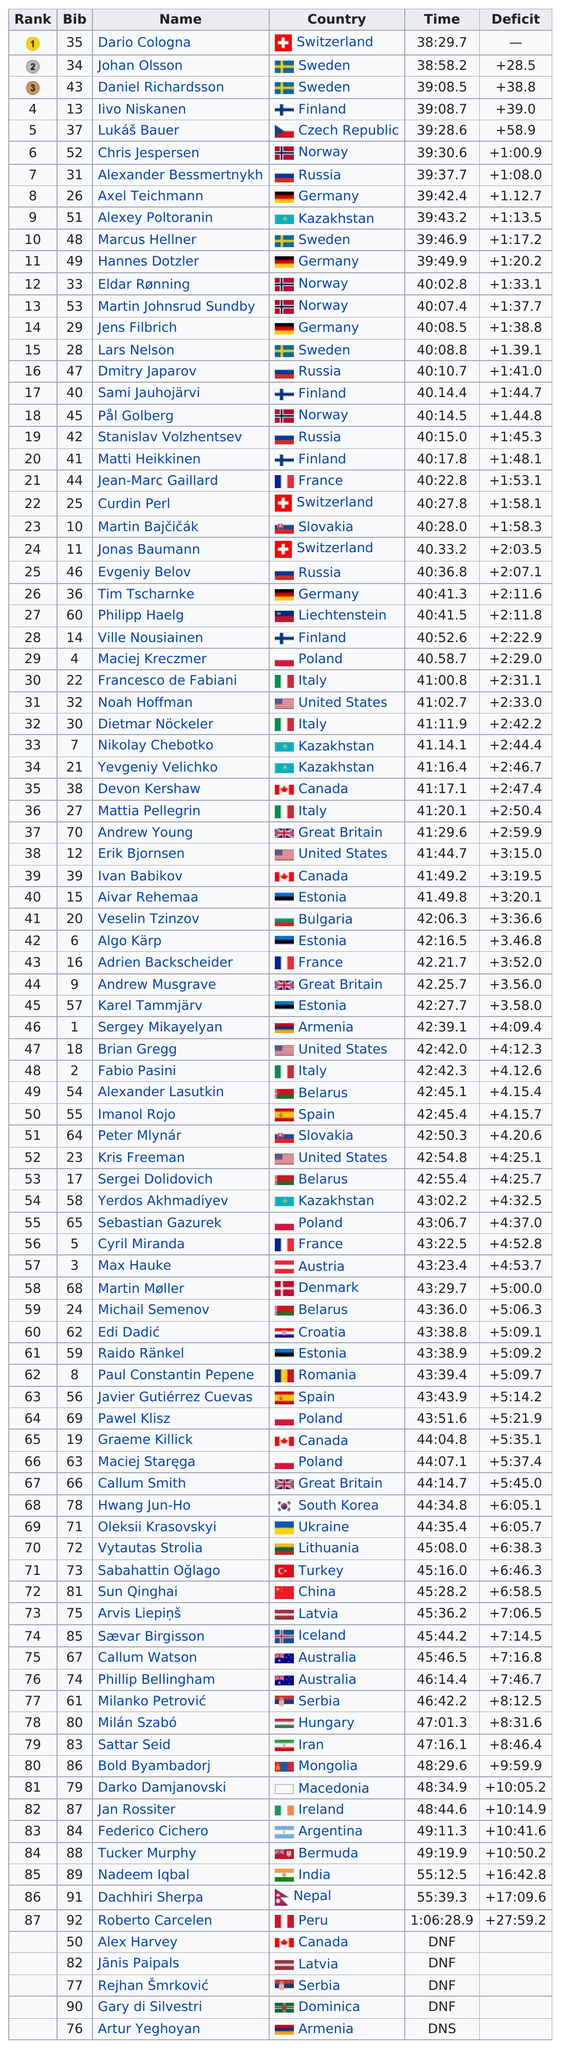Outline some significant characteristics in this image. Dario Cologna is the individual who placed first in a competition or event. The United States is listed as a country 4 times. Four German athletes competed in the men's 15 kilometer classical cross-country skiing event at the 2014 Winter Olympics. After Chris Jespersen of Norway, Alexander Bessmertnykh came in next. Out of the countries that completed the task within the time limit, how many had a time lower than 39 hours and 00 minutes? 